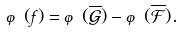<formula> <loc_0><loc_0><loc_500><loc_500>\varphi ( f ) = \varphi ( \overline { \mathcal { G } } ) - \varphi ( \overline { \mathcal { F } } ) .</formula> 